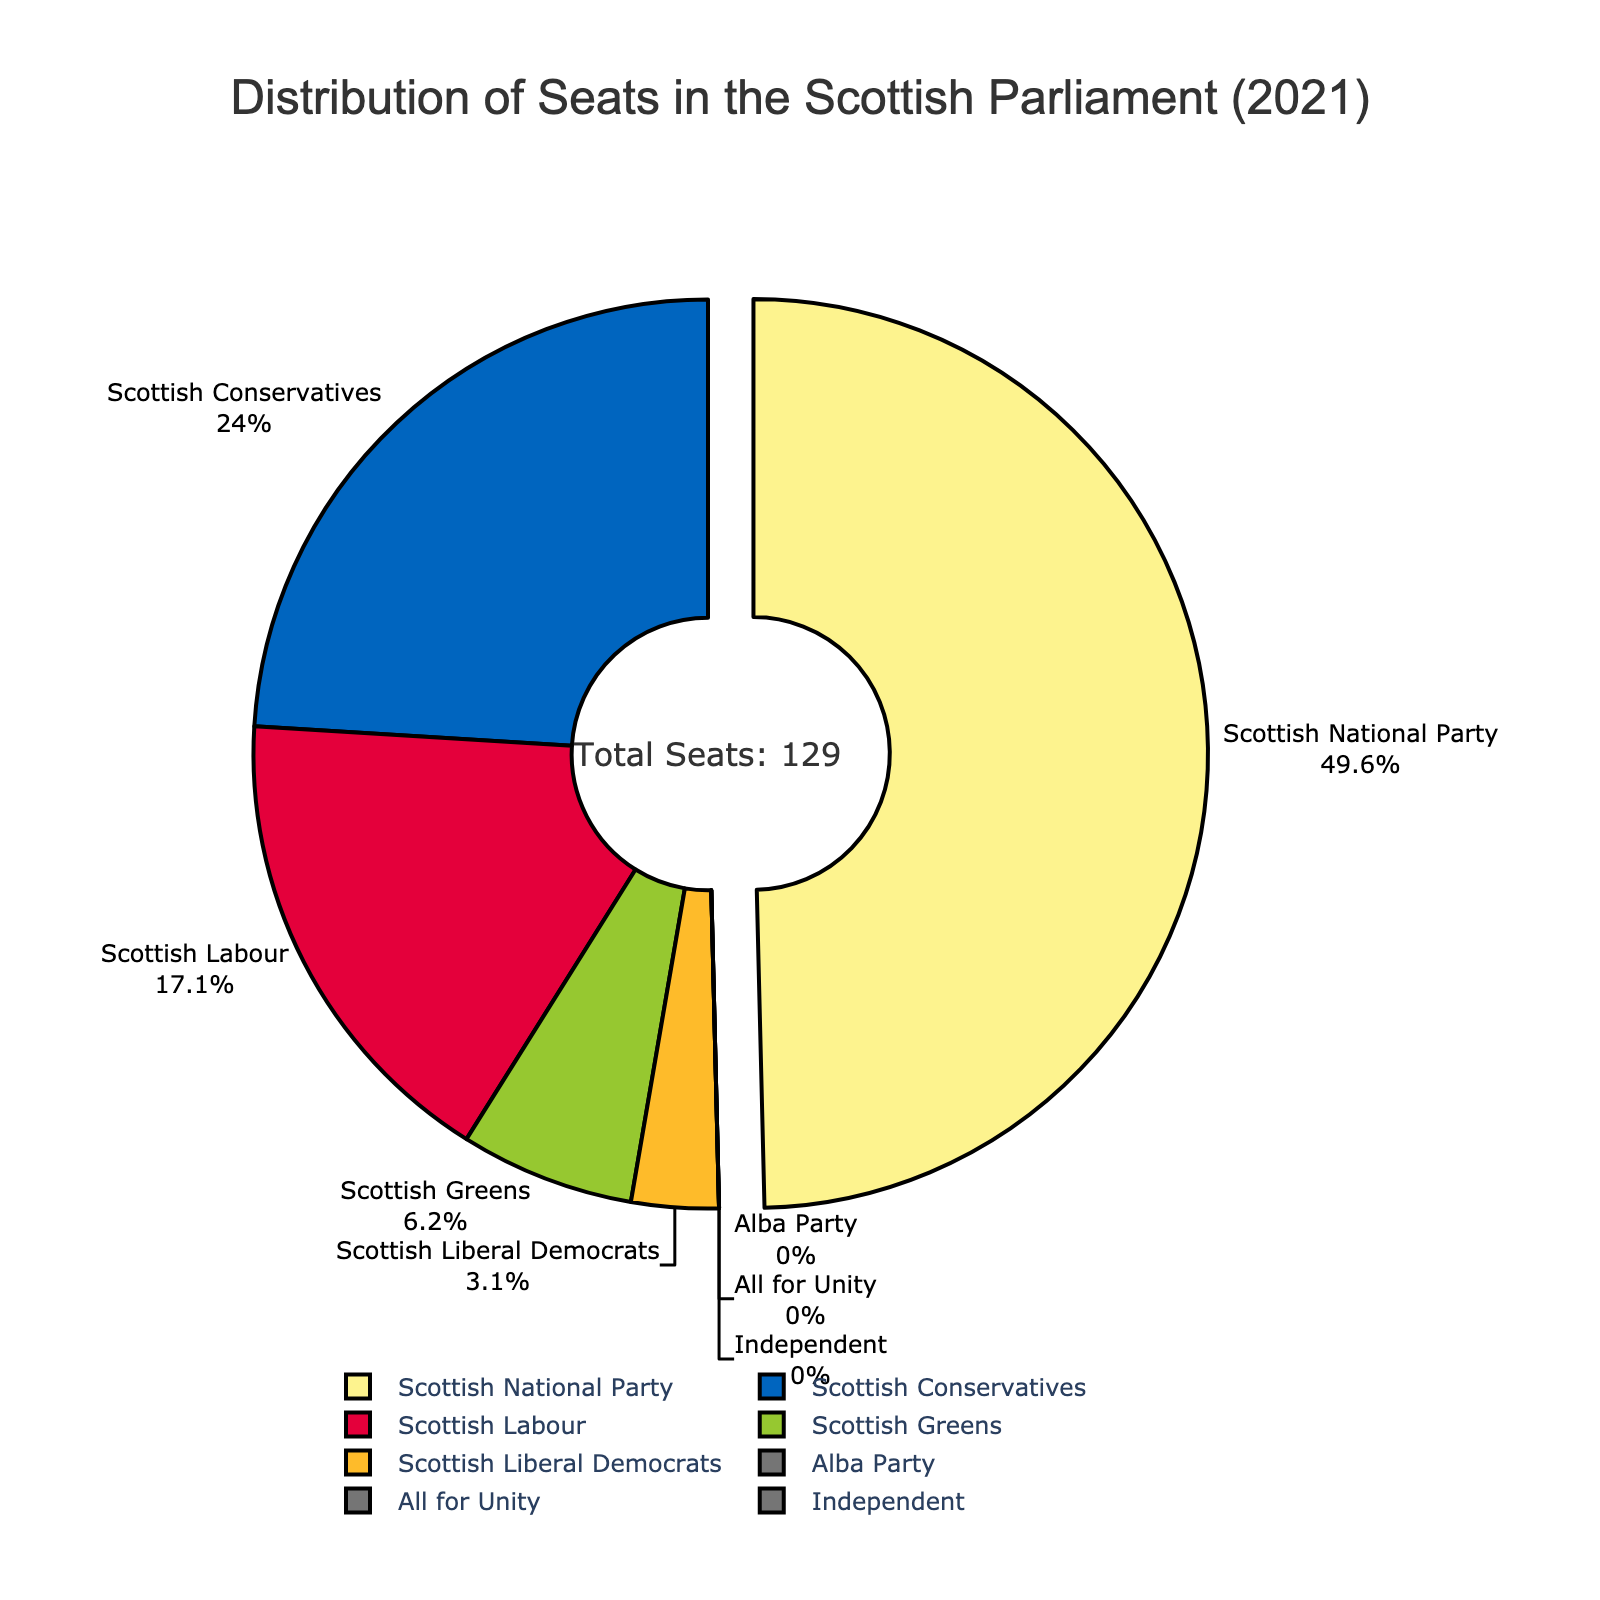What percentage of seats does the Scottish National Party hold? The pie chart shows labels with the party names and respective percentages. Find the Scottish National Party label, which indicates the percentage of seats.
Answer: 49.6% Which party has the second-highest number of seats? Look at the labels on the pie chart and find the party with the second-largest percentage after the Scottish National Party. The Scottish Conservatives should be observed.
Answer: Scottish Conservatives How many seats do the three smallest parties collectively hold? Identify the three parties with the smallest number of seats (Scottish Liberal Democrats, Alba Party, All for Unity, and Independent all have a very low number). Sum up their seats: 4 + 0 + 0 + 0.
Answer: 4 Compare the number of seats held by the Scottish Conservatives and Scottish Labour. How many more or fewer seats does each party have than the other? Find the seats for both parties (Scottish Conservatives: 31 seats, Scottish Labour: 22 seats). Calculate the difference: 31 - 22.
Answer: 9 more seats for Scottish Conservatives What is the total number of seats held by the Scottish National Party and Scottish Greens combined? Add the seats of the Scottish National Party and the Scottish Greens: 64 (SNP) + 8 (Scottish Greens).
Answer: 72 Which party holds more seats: Scottish Labour or Scottish Greens? Find the seat numbers for both parties. Scottish Labour holds 22 seats and Scottish Greens hold 8 seats. Compare the two numbers.
Answer: Scottish Labour Are there any parties that did not win any seats? If so, which ones? Look for parties that have labels with 0 seats on the pie chart. Identify those parties.
Answer: Alba Party, All for Unity, Independent What is the proportion of the seats held by the Scottish Conservatives relative to the total number of seats? The Scottish Conservatives hold 31 seats. The total number of seats is 129 (given in the annotation). Calculate the proportion: 31/129. Multiply by 100 to get the percentage.
Answer: About 24% How does the number of seats held by the Scottish Liberal Democrats compare to the number of seats held by the Scottish Greens? Compare the seats for the Scottish Liberal Democrats (4) and the Scottish Greens (8).
Answer: Scottish Greens have 4 more seats 